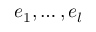<formula> <loc_0><loc_0><loc_500><loc_500>e _ { 1 } , \dots , e _ { l }</formula> 